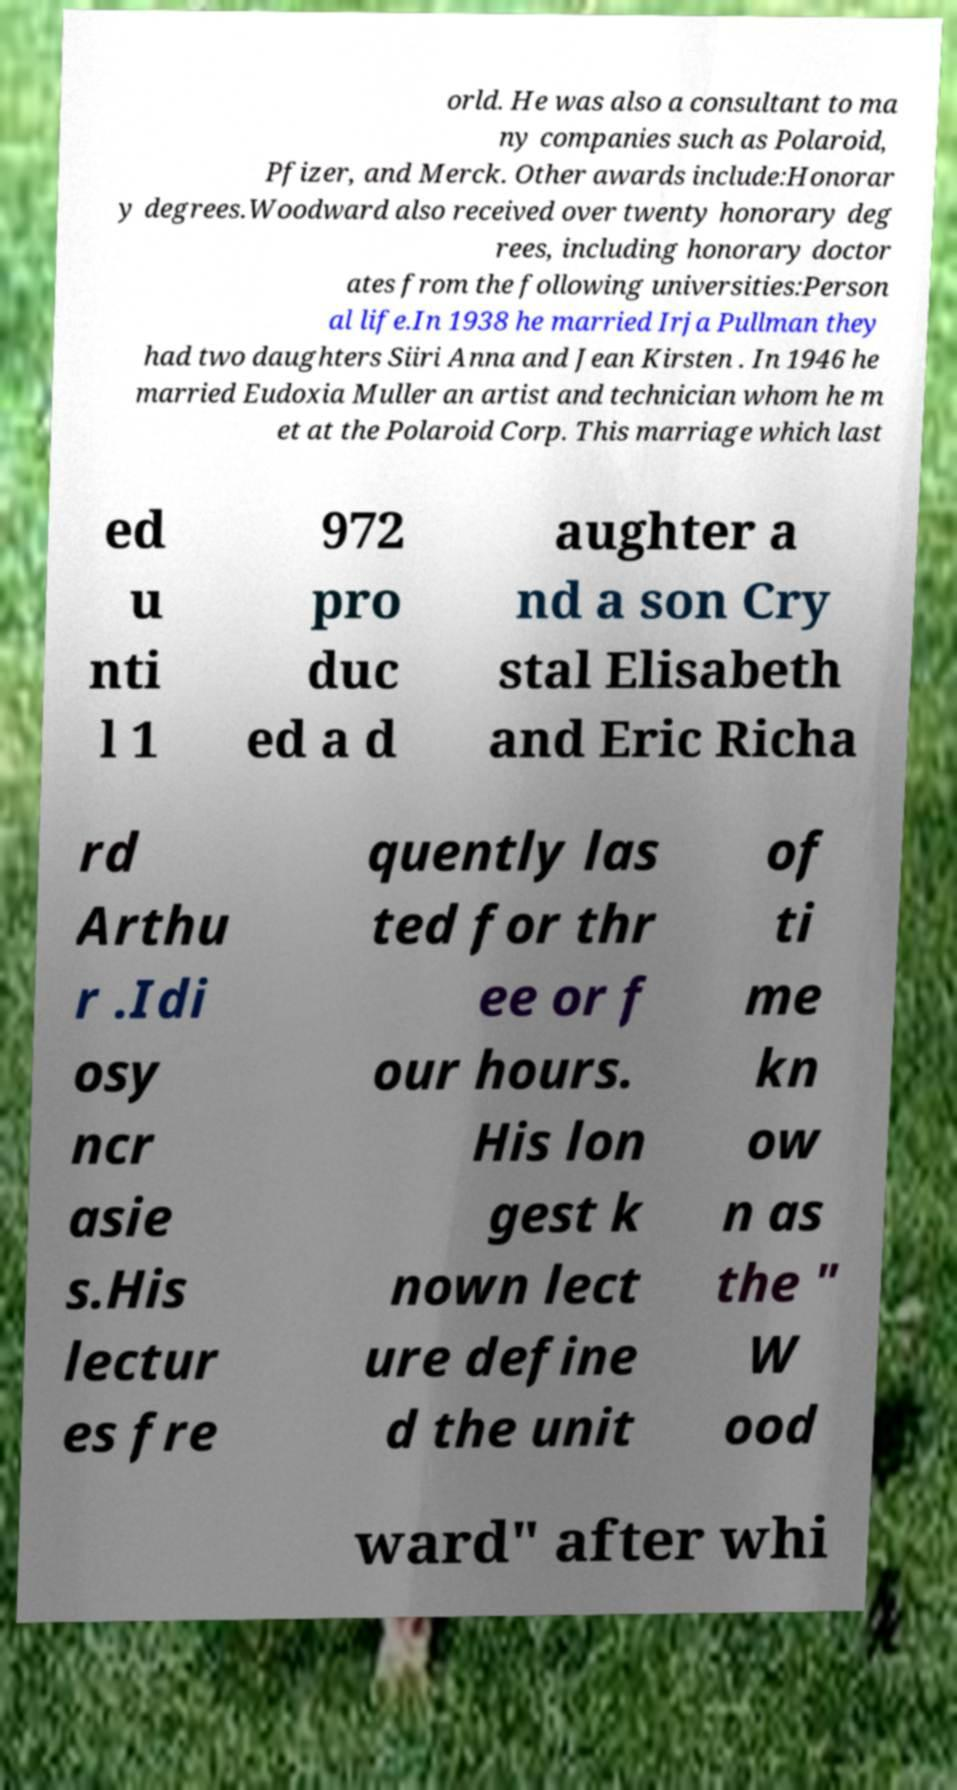Could you extract and type out the text from this image? orld. He was also a consultant to ma ny companies such as Polaroid, Pfizer, and Merck. Other awards include:Honorar y degrees.Woodward also received over twenty honorary deg rees, including honorary doctor ates from the following universities:Person al life.In 1938 he married Irja Pullman they had two daughters Siiri Anna and Jean Kirsten . In 1946 he married Eudoxia Muller an artist and technician whom he m et at the Polaroid Corp. This marriage which last ed u nti l 1 972 pro duc ed a d aughter a nd a son Cry stal Elisabeth and Eric Richa rd Arthu r .Idi osy ncr asie s.His lectur es fre quently las ted for thr ee or f our hours. His lon gest k nown lect ure define d the unit of ti me kn ow n as the " W ood ward" after whi 